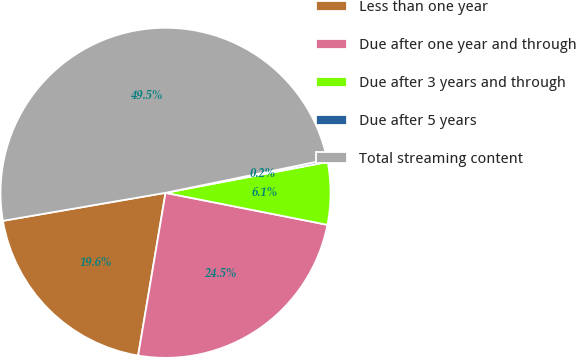<chart> <loc_0><loc_0><loc_500><loc_500><pie_chart><fcel>Less than one year<fcel>Due after one year and through<fcel>Due after 3 years and through<fcel>Due after 5 years<fcel>Total streaming content<nl><fcel>19.63%<fcel>24.55%<fcel>6.1%<fcel>0.23%<fcel>49.49%<nl></chart> 